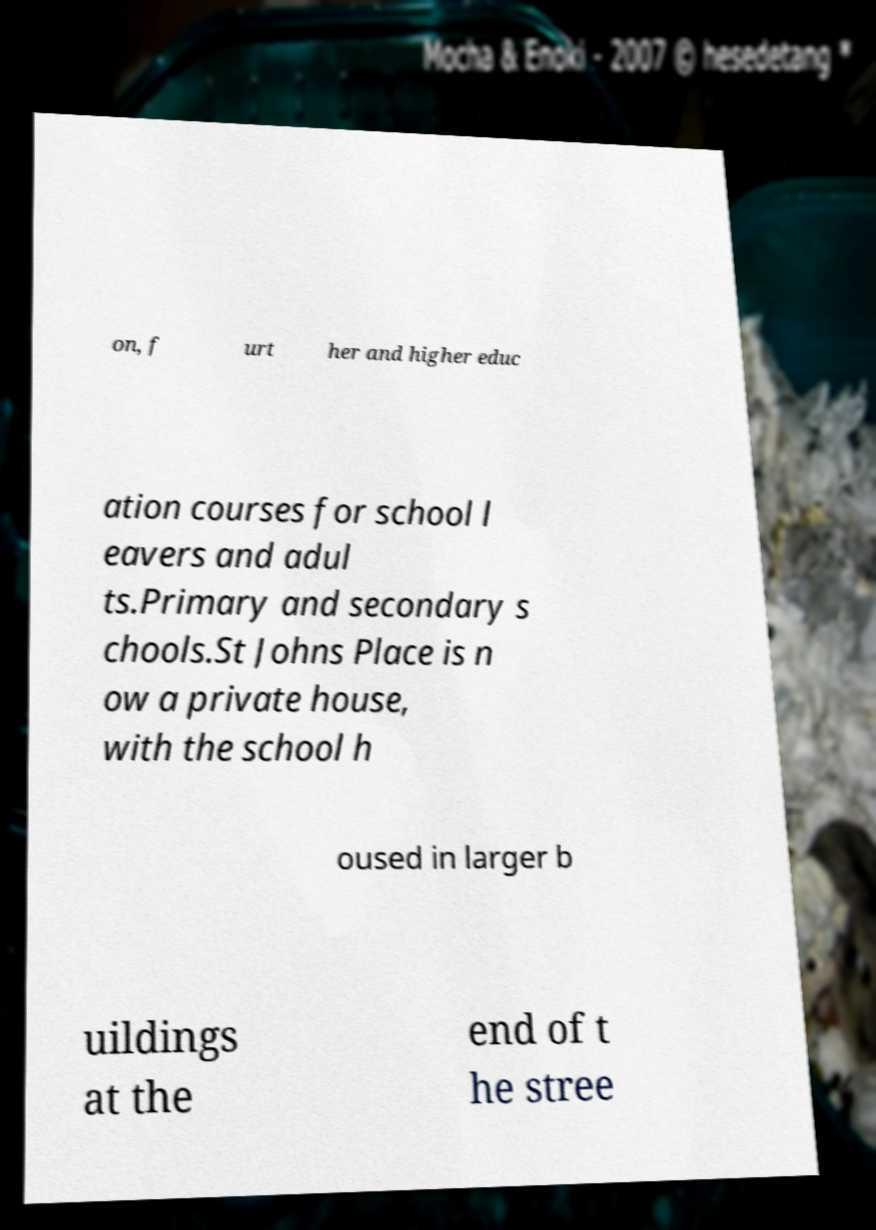Please read and relay the text visible in this image. What does it say? on, f urt her and higher educ ation courses for school l eavers and adul ts.Primary and secondary s chools.St Johns Place is n ow a private house, with the school h oused in larger b uildings at the end of t he stree 